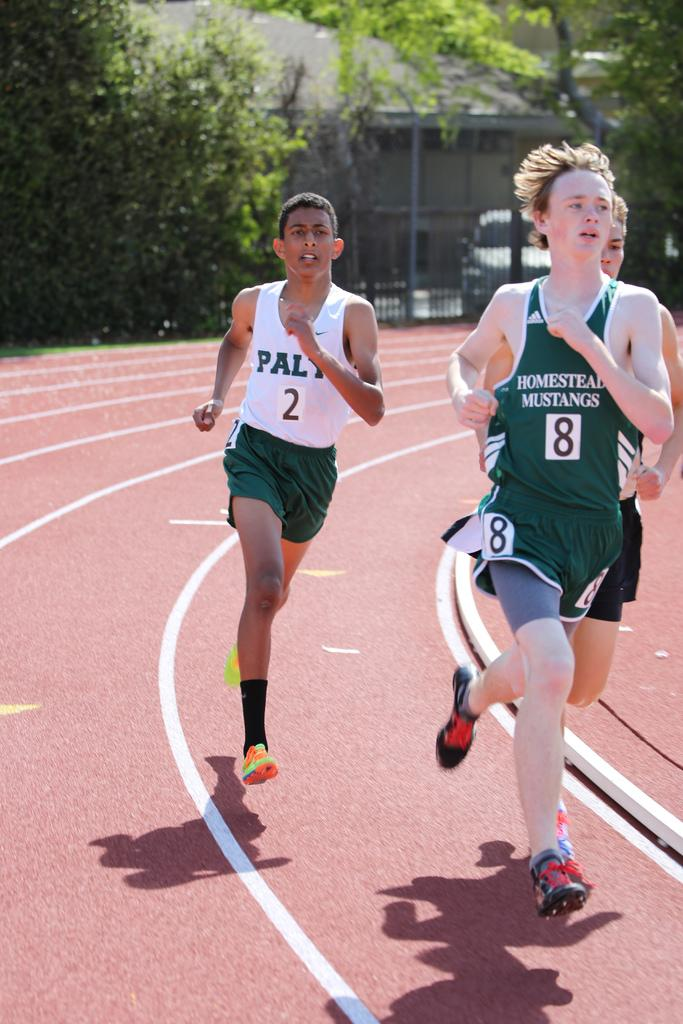Provide a one-sentence caption for the provided image. Homestead Mustangs runner number 8 against PALY runner number 2. 